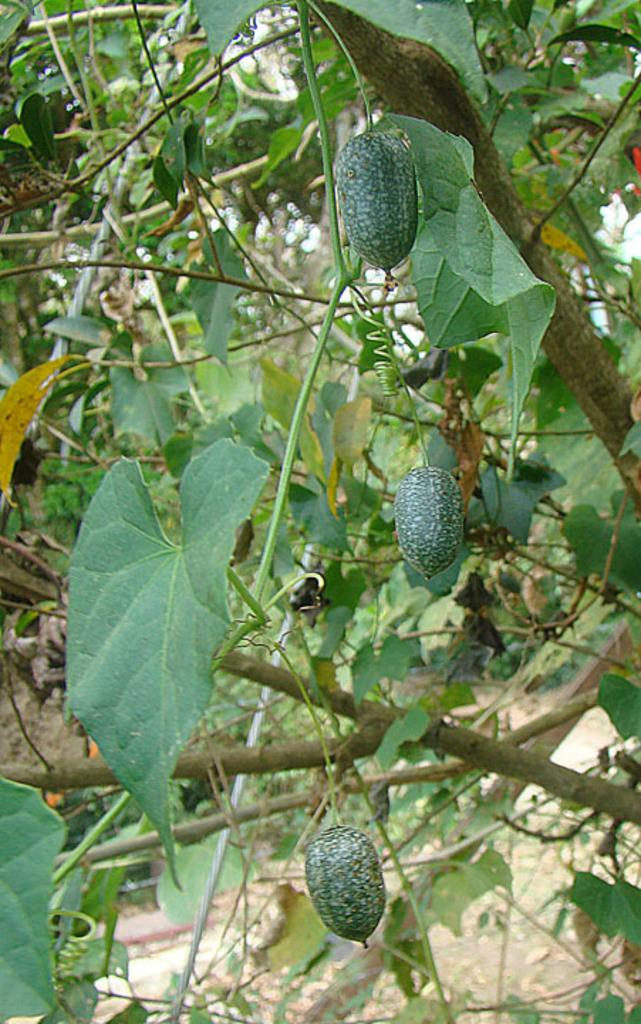What is present in the image that represents a plant? There is a tree in the image. What can be found on the tree in the image? The tree has fruits. Can you describe any other living organism in the image? There is a bug on a leaf in the image. What type of honey can be seen dripping from the tree in the image? There is no honey present in the image; it features a tree with fruits and a bug on a leaf. What type of wool is visible on the bug in the image? There is no wool present in the image; the bug is on a leaf of the tree. 